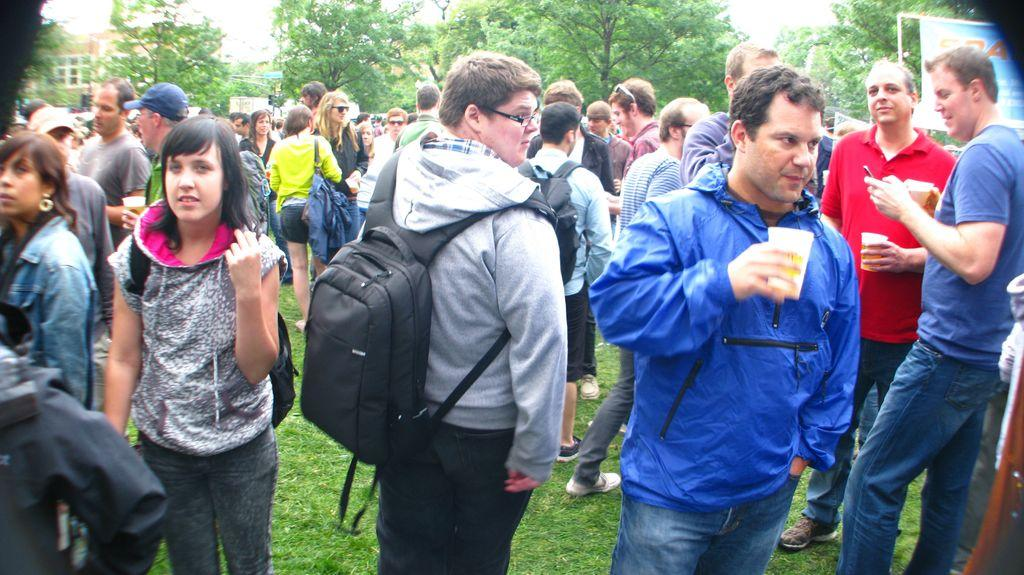What is the surface that the people are standing on in the image? The people are standing on the grass in the image. What can be seen in the background of the image? There are trees, buildings, and the sky visible in the background of the image. How many tickets are required to enter the garden in the image? There is no garden or tickets present in the image. What year is depicted in the image? The image does not depict a specific year; it is a snapshot of a scene at a particular moment in time. 